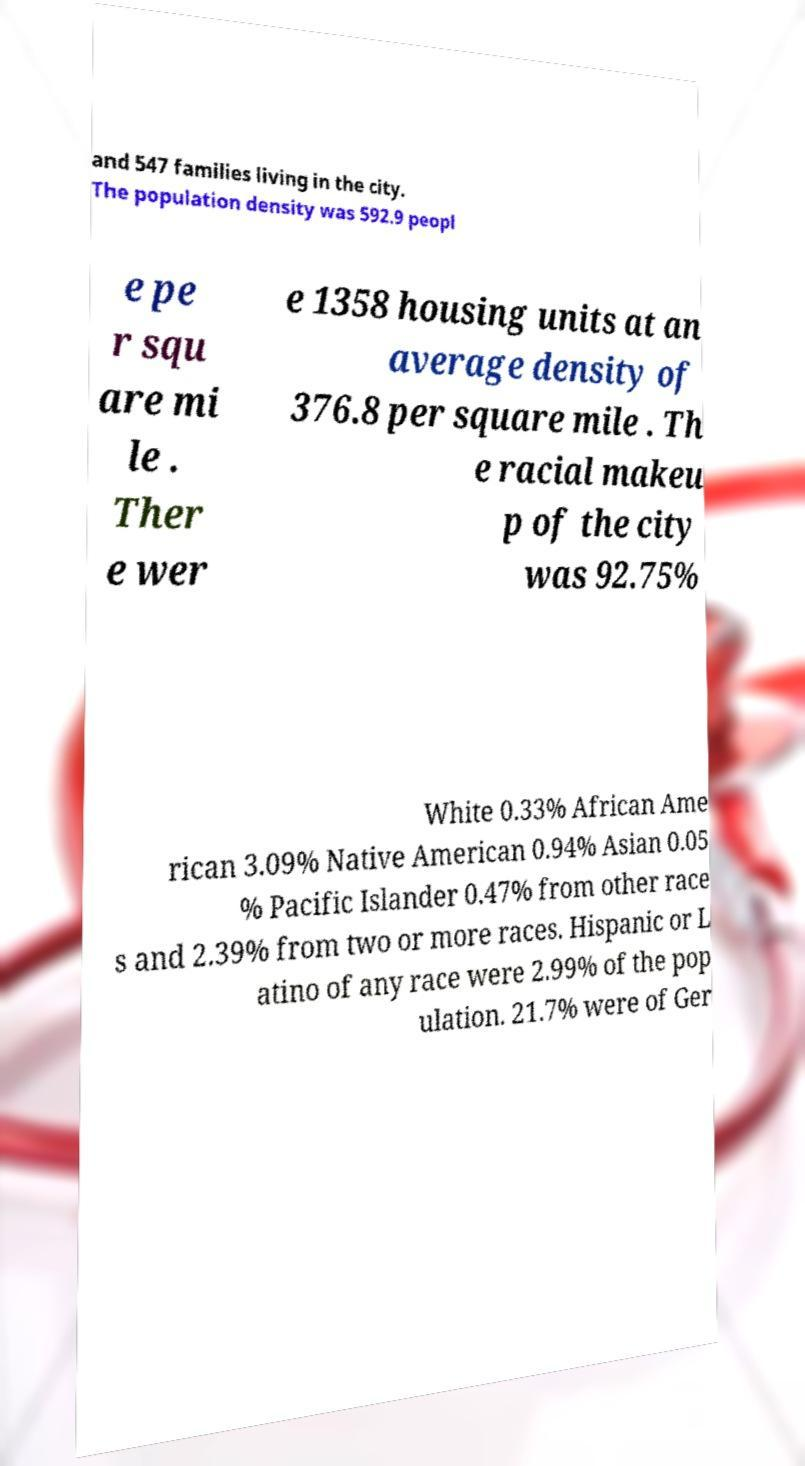Please read and relay the text visible in this image. What does it say? and 547 families living in the city. The population density was 592.9 peopl e pe r squ are mi le . Ther e wer e 1358 housing units at an average density of 376.8 per square mile . Th e racial makeu p of the city was 92.75% White 0.33% African Ame rican 3.09% Native American 0.94% Asian 0.05 % Pacific Islander 0.47% from other race s and 2.39% from two or more races. Hispanic or L atino of any race were 2.99% of the pop ulation. 21.7% were of Ger 